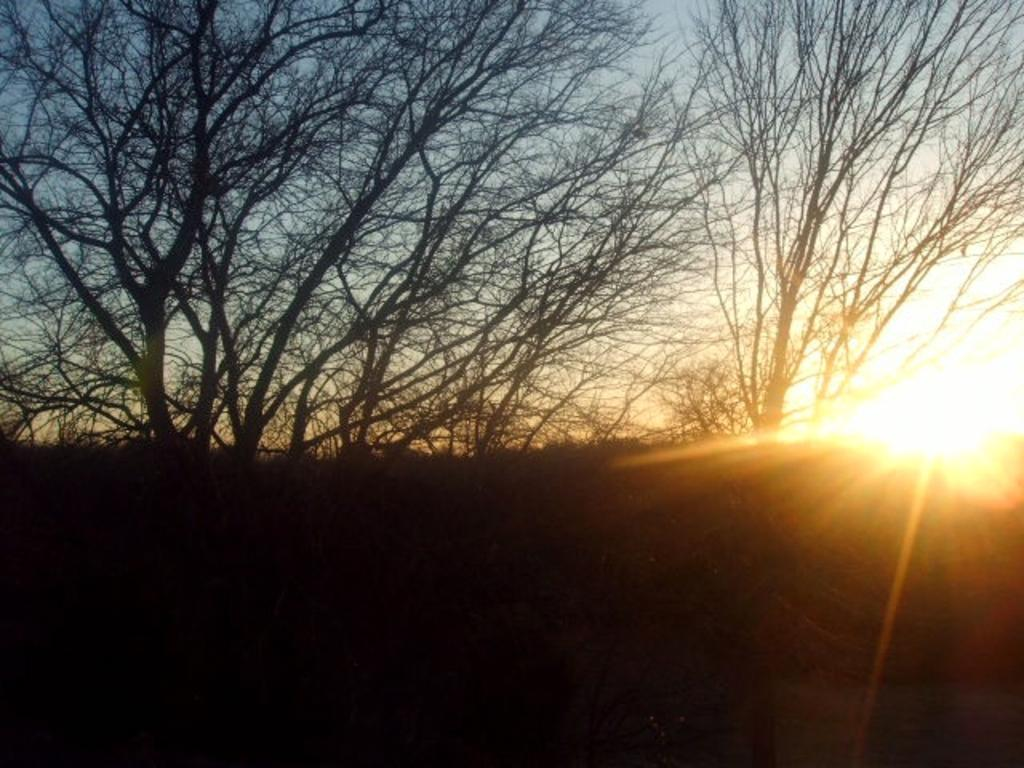What type of natural elements can be seen in the image? There are trees in the image. What is the color of the bottom part of the image? The bottom of the picture is black in color. Where is the sun located in the image? The sun is visible on the right side of the image. What type of market can be seen in the image? There is no market present in the image; it features trees and the sun. What type of canvas is used for the image? The type of canvas used for the image cannot be determined from the image itself. 